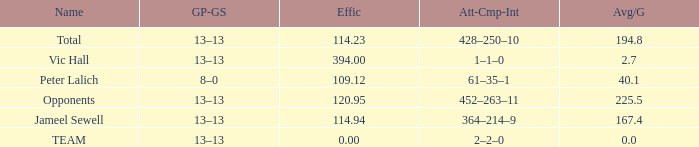Avg/G of 2.7 is what effic? 394.0. 